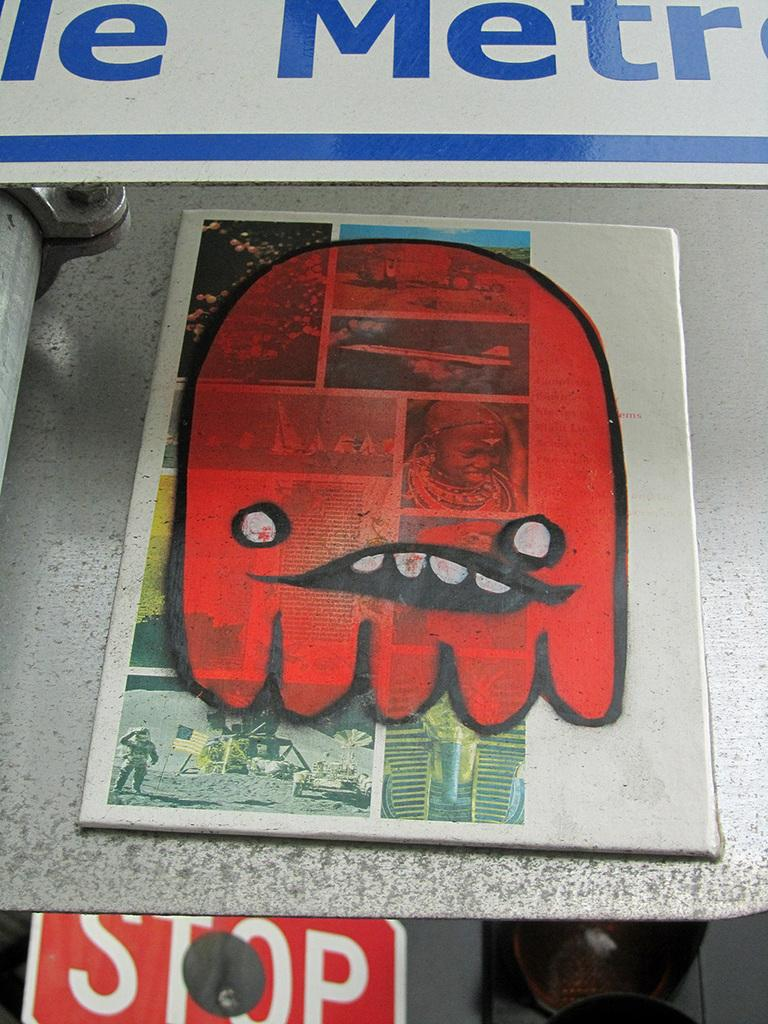<image>
Render a clear and concise summary of the photo. A red monster drawn on a magazine page above a stop sign. 